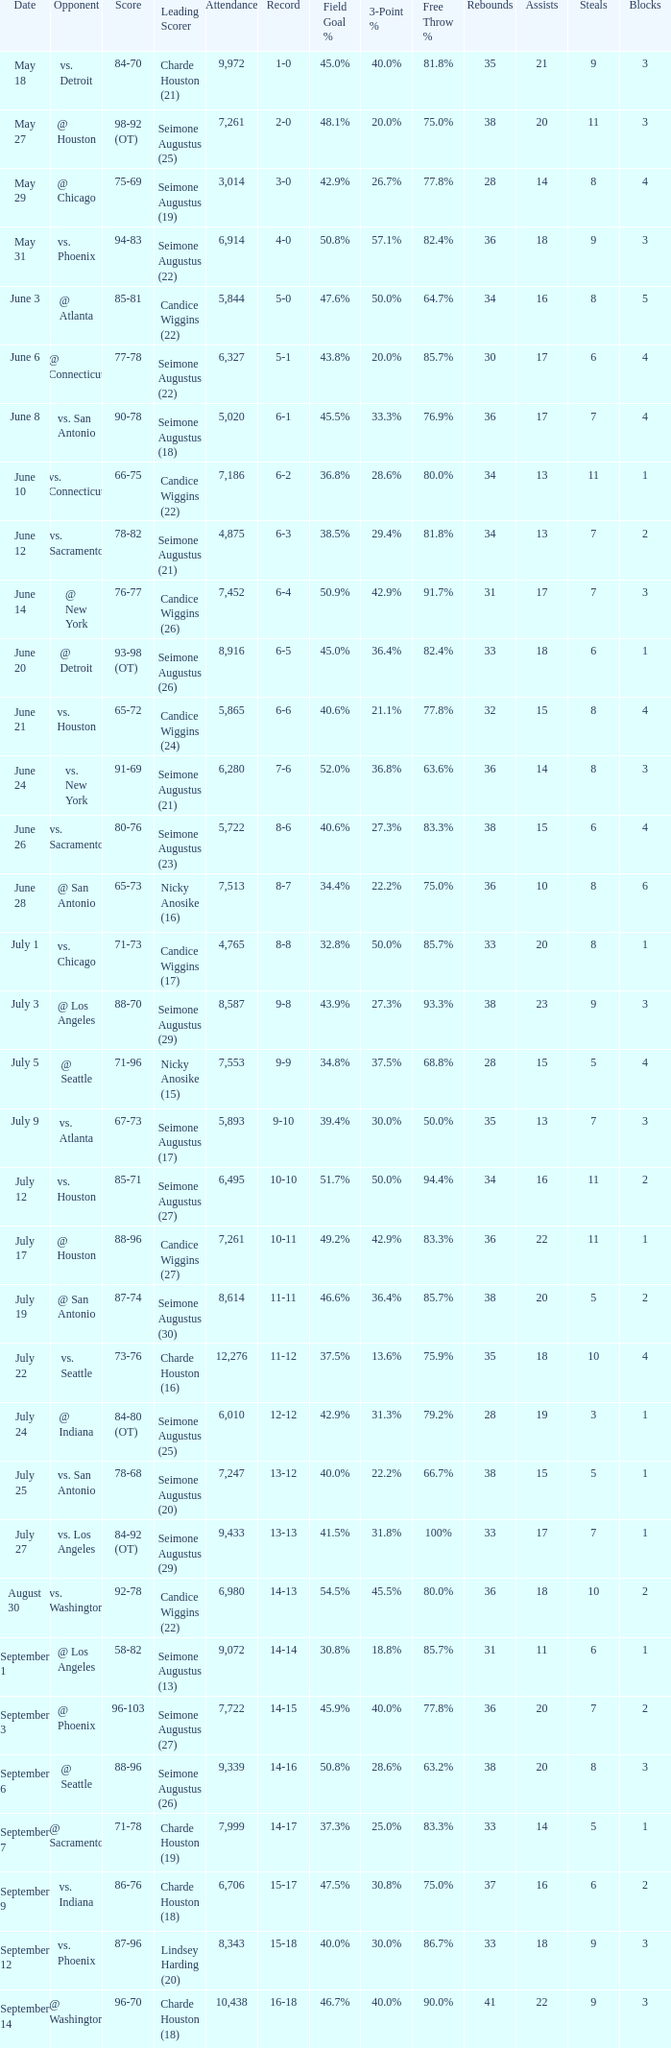Which Score has an Opponent of @ houston, and a Record of 2-0? 98-92 (OT). 